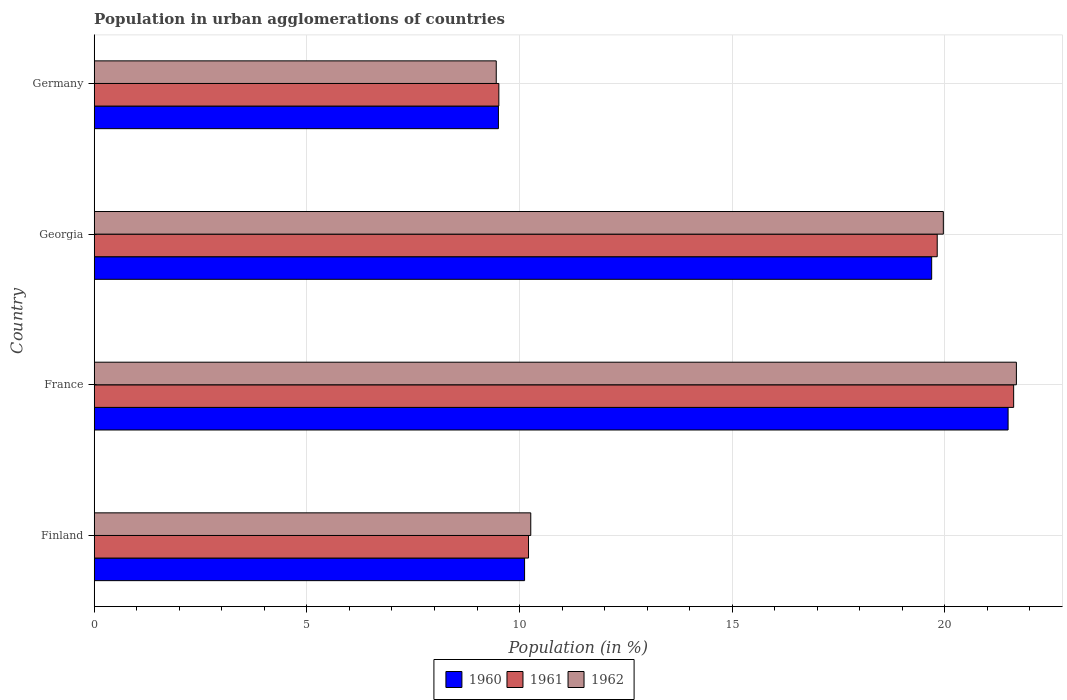How many different coloured bars are there?
Keep it short and to the point. 3. How many bars are there on the 3rd tick from the top?
Offer a very short reply. 3. How many bars are there on the 3rd tick from the bottom?
Keep it short and to the point. 3. In how many cases, is the number of bars for a given country not equal to the number of legend labels?
Ensure brevity in your answer.  0. What is the percentage of population in urban agglomerations in 1960 in Finland?
Provide a succinct answer. 10.12. Across all countries, what is the maximum percentage of population in urban agglomerations in 1962?
Provide a succinct answer. 21.68. Across all countries, what is the minimum percentage of population in urban agglomerations in 1962?
Offer a terse response. 9.45. What is the total percentage of population in urban agglomerations in 1961 in the graph?
Your answer should be very brief. 61.16. What is the difference between the percentage of population in urban agglomerations in 1960 in Finland and that in France?
Your answer should be compact. -11.37. What is the difference between the percentage of population in urban agglomerations in 1962 in Germany and the percentage of population in urban agglomerations in 1961 in Georgia?
Provide a succinct answer. -10.37. What is the average percentage of population in urban agglomerations in 1962 per country?
Keep it short and to the point. 15.34. What is the difference between the percentage of population in urban agglomerations in 1960 and percentage of population in urban agglomerations in 1962 in France?
Ensure brevity in your answer.  -0.19. In how many countries, is the percentage of population in urban agglomerations in 1961 greater than 17 %?
Give a very brief answer. 2. What is the ratio of the percentage of population in urban agglomerations in 1960 in France to that in Georgia?
Your response must be concise. 1.09. Is the percentage of population in urban agglomerations in 1962 in France less than that in Georgia?
Provide a short and direct response. No. What is the difference between the highest and the second highest percentage of population in urban agglomerations in 1962?
Offer a very short reply. 1.72. What is the difference between the highest and the lowest percentage of population in urban agglomerations in 1962?
Your answer should be very brief. 12.23. In how many countries, is the percentage of population in urban agglomerations in 1961 greater than the average percentage of population in urban agglomerations in 1961 taken over all countries?
Provide a short and direct response. 2. What does the 3rd bar from the bottom in Finland represents?
Keep it short and to the point. 1962. How many countries are there in the graph?
Offer a terse response. 4. Does the graph contain grids?
Make the answer very short. Yes. Where does the legend appear in the graph?
Provide a short and direct response. Bottom center. How are the legend labels stacked?
Provide a short and direct response. Horizontal. What is the title of the graph?
Provide a short and direct response. Population in urban agglomerations of countries. What is the label or title of the X-axis?
Offer a terse response. Population (in %). What is the Population (in %) of 1960 in Finland?
Provide a succinct answer. 10.12. What is the Population (in %) in 1961 in Finland?
Give a very brief answer. 10.21. What is the Population (in %) of 1962 in Finland?
Keep it short and to the point. 10.26. What is the Population (in %) of 1960 in France?
Make the answer very short. 21.49. What is the Population (in %) in 1961 in France?
Give a very brief answer. 21.62. What is the Population (in %) of 1962 in France?
Offer a terse response. 21.68. What is the Population (in %) of 1960 in Georgia?
Ensure brevity in your answer.  19.69. What is the Population (in %) in 1961 in Georgia?
Your answer should be compact. 19.82. What is the Population (in %) of 1962 in Georgia?
Offer a terse response. 19.96. What is the Population (in %) of 1960 in Germany?
Give a very brief answer. 9.5. What is the Population (in %) of 1961 in Germany?
Ensure brevity in your answer.  9.51. What is the Population (in %) in 1962 in Germany?
Your response must be concise. 9.45. Across all countries, what is the maximum Population (in %) of 1960?
Offer a very short reply. 21.49. Across all countries, what is the maximum Population (in %) of 1961?
Offer a terse response. 21.62. Across all countries, what is the maximum Population (in %) in 1962?
Keep it short and to the point. 21.68. Across all countries, what is the minimum Population (in %) in 1960?
Provide a succinct answer. 9.5. Across all countries, what is the minimum Population (in %) in 1961?
Make the answer very short. 9.51. Across all countries, what is the minimum Population (in %) in 1962?
Give a very brief answer. 9.45. What is the total Population (in %) of 1960 in the graph?
Your response must be concise. 60.79. What is the total Population (in %) of 1961 in the graph?
Make the answer very short. 61.16. What is the total Population (in %) in 1962 in the graph?
Your answer should be compact. 61.36. What is the difference between the Population (in %) of 1960 in Finland and that in France?
Offer a very short reply. -11.37. What is the difference between the Population (in %) of 1961 in Finland and that in France?
Your answer should be compact. -11.41. What is the difference between the Population (in %) of 1962 in Finland and that in France?
Offer a very short reply. -11.42. What is the difference between the Population (in %) in 1960 in Finland and that in Georgia?
Give a very brief answer. -9.57. What is the difference between the Population (in %) in 1961 in Finland and that in Georgia?
Give a very brief answer. -9.61. What is the difference between the Population (in %) in 1962 in Finland and that in Georgia?
Ensure brevity in your answer.  -9.7. What is the difference between the Population (in %) of 1960 in Finland and that in Germany?
Provide a short and direct response. 0.62. What is the difference between the Population (in %) in 1961 in Finland and that in Germany?
Offer a very short reply. 0.7. What is the difference between the Population (in %) of 1962 in Finland and that in Germany?
Make the answer very short. 0.81. What is the difference between the Population (in %) of 1960 in France and that in Georgia?
Offer a very short reply. 1.8. What is the difference between the Population (in %) in 1961 in France and that in Georgia?
Keep it short and to the point. 1.8. What is the difference between the Population (in %) in 1962 in France and that in Georgia?
Make the answer very short. 1.72. What is the difference between the Population (in %) of 1960 in France and that in Germany?
Provide a short and direct response. 11.98. What is the difference between the Population (in %) of 1961 in France and that in Germany?
Give a very brief answer. 12.1. What is the difference between the Population (in %) in 1962 in France and that in Germany?
Offer a very short reply. 12.23. What is the difference between the Population (in %) in 1960 in Georgia and that in Germany?
Keep it short and to the point. 10.19. What is the difference between the Population (in %) in 1961 in Georgia and that in Germany?
Offer a terse response. 10.31. What is the difference between the Population (in %) of 1962 in Georgia and that in Germany?
Give a very brief answer. 10.51. What is the difference between the Population (in %) in 1960 in Finland and the Population (in %) in 1961 in France?
Make the answer very short. -11.5. What is the difference between the Population (in %) in 1960 in Finland and the Population (in %) in 1962 in France?
Provide a short and direct response. -11.56. What is the difference between the Population (in %) in 1961 in Finland and the Population (in %) in 1962 in France?
Ensure brevity in your answer.  -11.47. What is the difference between the Population (in %) of 1960 in Finland and the Population (in %) of 1961 in Georgia?
Make the answer very short. -9.7. What is the difference between the Population (in %) in 1960 in Finland and the Population (in %) in 1962 in Georgia?
Offer a terse response. -9.84. What is the difference between the Population (in %) in 1961 in Finland and the Population (in %) in 1962 in Georgia?
Keep it short and to the point. -9.75. What is the difference between the Population (in %) in 1960 in Finland and the Population (in %) in 1961 in Germany?
Your answer should be compact. 0.6. What is the difference between the Population (in %) of 1960 in Finland and the Population (in %) of 1962 in Germany?
Provide a succinct answer. 0.67. What is the difference between the Population (in %) of 1961 in Finland and the Population (in %) of 1962 in Germany?
Ensure brevity in your answer.  0.76. What is the difference between the Population (in %) of 1960 in France and the Population (in %) of 1961 in Georgia?
Keep it short and to the point. 1.67. What is the difference between the Population (in %) in 1960 in France and the Population (in %) in 1962 in Georgia?
Your response must be concise. 1.52. What is the difference between the Population (in %) of 1961 in France and the Population (in %) of 1962 in Georgia?
Ensure brevity in your answer.  1.65. What is the difference between the Population (in %) in 1960 in France and the Population (in %) in 1961 in Germany?
Ensure brevity in your answer.  11.97. What is the difference between the Population (in %) of 1960 in France and the Population (in %) of 1962 in Germany?
Offer a terse response. 12.03. What is the difference between the Population (in %) of 1961 in France and the Population (in %) of 1962 in Germany?
Make the answer very short. 12.16. What is the difference between the Population (in %) in 1960 in Georgia and the Population (in %) in 1961 in Germany?
Your answer should be compact. 10.18. What is the difference between the Population (in %) in 1960 in Georgia and the Population (in %) in 1962 in Germany?
Provide a succinct answer. 10.24. What is the difference between the Population (in %) in 1961 in Georgia and the Population (in %) in 1962 in Germany?
Your response must be concise. 10.37. What is the average Population (in %) of 1960 per country?
Provide a succinct answer. 15.2. What is the average Population (in %) of 1961 per country?
Provide a succinct answer. 15.29. What is the average Population (in %) in 1962 per country?
Make the answer very short. 15.34. What is the difference between the Population (in %) in 1960 and Population (in %) in 1961 in Finland?
Give a very brief answer. -0.09. What is the difference between the Population (in %) of 1960 and Population (in %) of 1962 in Finland?
Offer a terse response. -0.15. What is the difference between the Population (in %) in 1961 and Population (in %) in 1962 in Finland?
Keep it short and to the point. -0.05. What is the difference between the Population (in %) in 1960 and Population (in %) in 1961 in France?
Your answer should be compact. -0.13. What is the difference between the Population (in %) in 1960 and Population (in %) in 1962 in France?
Offer a terse response. -0.19. What is the difference between the Population (in %) in 1961 and Population (in %) in 1962 in France?
Your answer should be very brief. -0.06. What is the difference between the Population (in %) of 1960 and Population (in %) of 1961 in Georgia?
Provide a succinct answer. -0.13. What is the difference between the Population (in %) of 1960 and Population (in %) of 1962 in Georgia?
Your answer should be compact. -0.27. What is the difference between the Population (in %) of 1961 and Population (in %) of 1962 in Georgia?
Give a very brief answer. -0.14. What is the difference between the Population (in %) in 1960 and Population (in %) in 1961 in Germany?
Give a very brief answer. -0.01. What is the difference between the Population (in %) of 1960 and Population (in %) of 1962 in Germany?
Your answer should be very brief. 0.05. What is the difference between the Population (in %) in 1961 and Population (in %) in 1962 in Germany?
Your answer should be compact. 0.06. What is the ratio of the Population (in %) in 1960 in Finland to that in France?
Give a very brief answer. 0.47. What is the ratio of the Population (in %) in 1961 in Finland to that in France?
Provide a succinct answer. 0.47. What is the ratio of the Population (in %) of 1962 in Finland to that in France?
Your response must be concise. 0.47. What is the ratio of the Population (in %) of 1960 in Finland to that in Georgia?
Offer a very short reply. 0.51. What is the ratio of the Population (in %) in 1961 in Finland to that in Georgia?
Ensure brevity in your answer.  0.52. What is the ratio of the Population (in %) in 1962 in Finland to that in Georgia?
Ensure brevity in your answer.  0.51. What is the ratio of the Population (in %) of 1960 in Finland to that in Germany?
Make the answer very short. 1.06. What is the ratio of the Population (in %) of 1961 in Finland to that in Germany?
Make the answer very short. 1.07. What is the ratio of the Population (in %) of 1962 in Finland to that in Germany?
Give a very brief answer. 1.09. What is the ratio of the Population (in %) of 1960 in France to that in Georgia?
Make the answer very short. 1.09. What is the ratio of the Population (in %) of 1961 in France to that in Georgia?
Your answer should be compact. 1.09. What is the ratio of the Population (in %) in 1962 in France to that in Georgia?
Provide a short and direct response. 1.09. What is the ratio of the Population (in %) of 1960 in France to that in Germany?
Offer a terse response. 2.26. What is the ratio of the Population (in %) of 1961 in France to that in Germany?
Provide a short and direct response. 2.27. What is the ratio of the Population (in %) in 1962 in France to that in Germany?
Ensure brevity in your answer.  2.29. What is the ratio of the Population (in %) of 1960 in Georgia to that in Germany?
Offer a very short reply. 2.07. What is the ratio of the Population (in %) of 1961 in Georgia to that in Germany?
Offer a very short reply. 2.08. What is the ratio of the Population (in %) in 1962 in Georgia to that in Germany?
Keep it short and to the point. 2.11. What is the difference between the highest and the second highest Population (in %) of 1960?
Keep it short and to the point. 1.8. What is the difference between the highest and the second highest Population (in %) of 1961?
Provide a succinct answer. 1.8. What is the difference between the highest and the second highest Population (in %) in 1962?
Give a very brief answer. 1.72. What is the difference between the highest and the lowest Population (in %) in 1960?
Offer a terse response. 11.98. What is the difference between the highest and the lowest Population (in %) in 1961?
Make the answer very short. 12.1. What is the difference between the highest and the lowest Population (in %) in 1962?
Give a very brief answer. 12.23. 